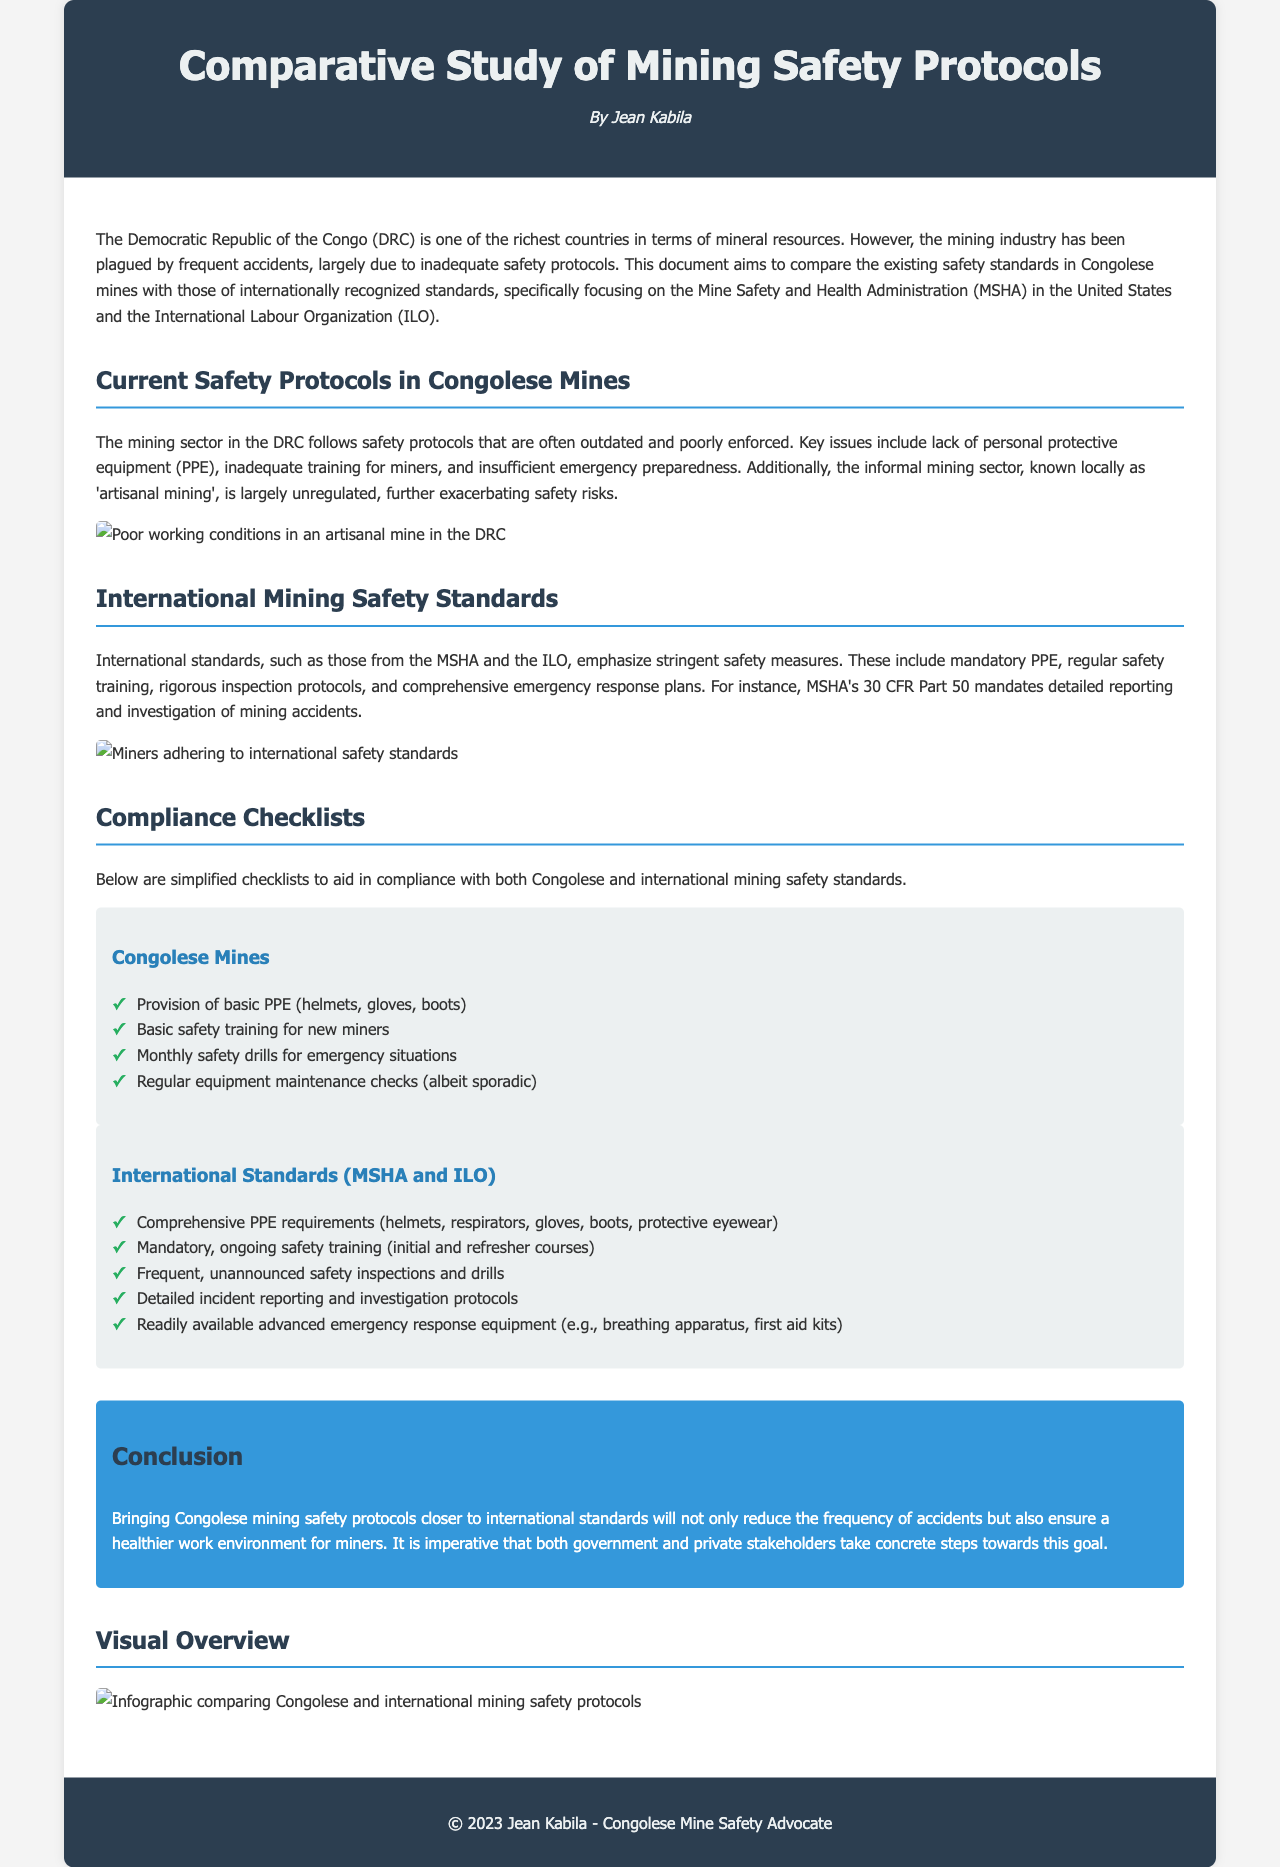What is the main aim of the document? The document aims to compare existing safety standards in Congolese mines with internationally recognized standards.
Answer: Compare existing safety standards What issues are highlighted regarding the Congolese mines? Key issues include lack of personal protective equipment, inadequate training, and insufficient emergency preparedness.
Answer: Lack of PPE, inadequate training, insufficient emergency preparedness What international organization’s standards are compared in this study? The document specifically focuses on the Mine Safety and Health Administration (MSHA) and the International Labour Organization (ILO).
Answer: MSHA and ILO What is a key requirement of MSHA regarding accident reporting? MSHA's 30 CFR Part 50 mandates detailed reporting and investigation of mining accidents.
Answer: Detailed reporting and investigation How often should safety drills be conducted in Congolese mines according to the checklist? The checklist suggests monthly safety drills for emergency situations.
Answer: Monthly What type of protective equipment is specified in the international standards checklist? Comprehensive PPE includes helmets, respirators, gloves, boots, and protective eyewear.
Answer: Helmets, respirators, gloves, boots, protective eyewear What infographic is mentioned in the document? The document includes an infographic comparing Congolese and international mining safety protocols.
Answer: Infographic comparing protocols What is the color of the conclusion section's background? The conclusion section's background is a shade of blue.
Answer: Blue What is the purpose of the compliance checklists? The compliance checklists aid in compliance with both Congolese and international mining safety standards.
Answer: Aid in compliance 